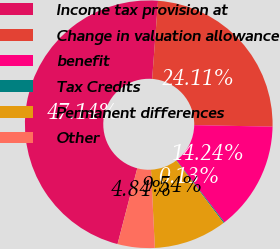Convert chart. <chart><loc_0><loc_0><loc_500><loc_500><pie_chart><fcel>Income tax provision at<fcel>Change in valuation allowance<fcel>benefit<fcel>Tax Credits<fcel>Permanent differences<fcel>Other<nl><fcel>47.14%<fcel>24.11%<fcel>14.24%<fcel>0.13%<fcel>9.54%<fcel>4.84%<nl></chart> 